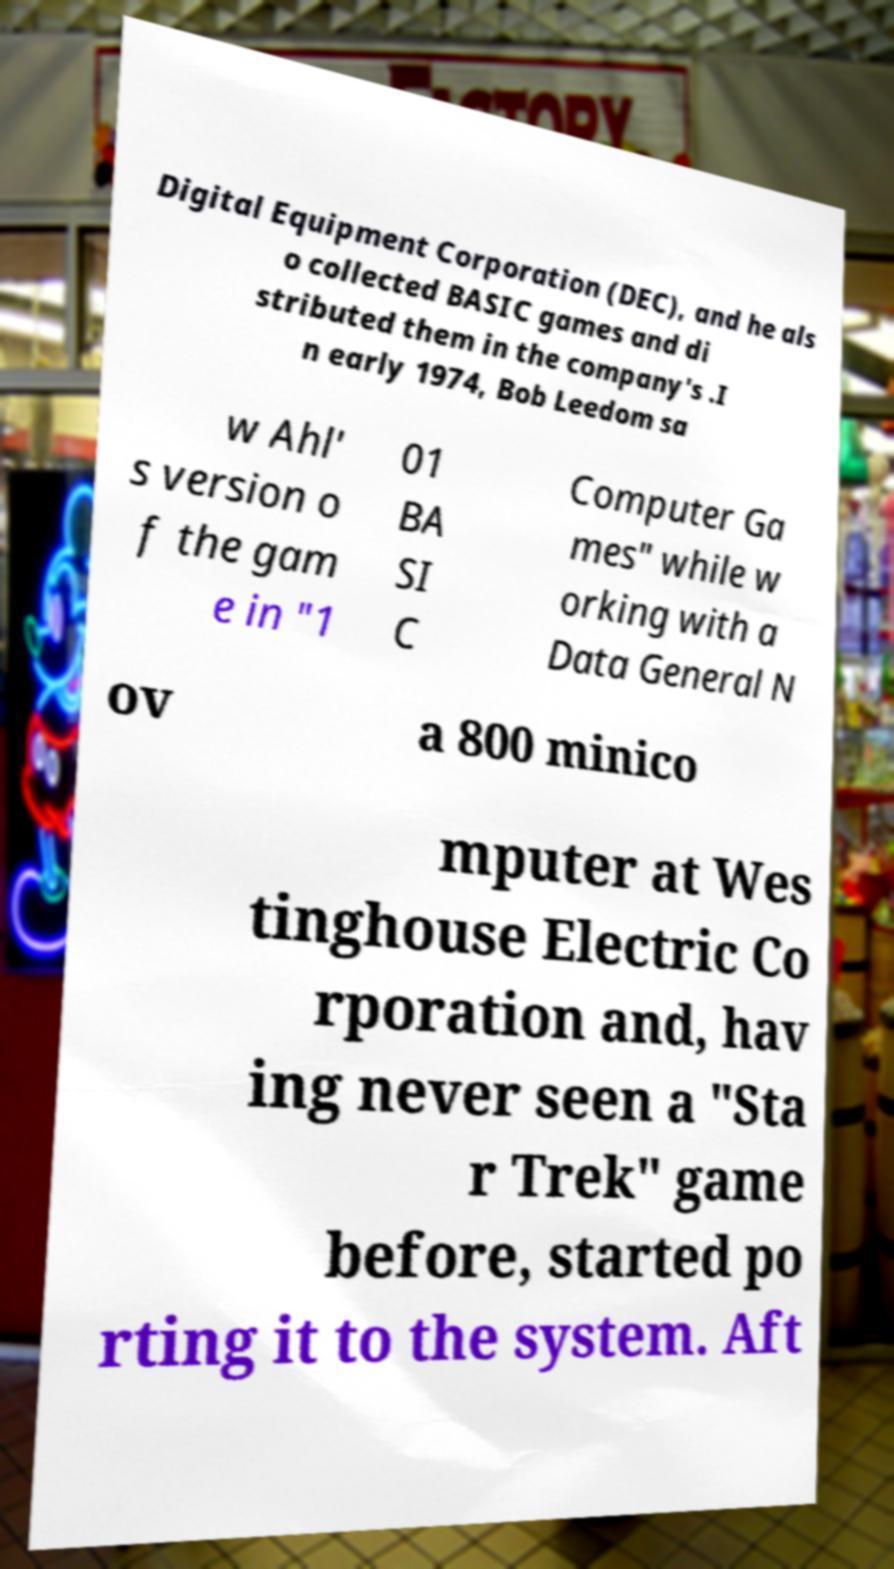What messages or text are displayed in this image? I need them in a readable, typed format. Digital Equipment Corporation (DEC), and he als o collected BASIC games and di stributed them in the company's .I n early 1974, Bob Leedom sa w Ahl' s version o f the gam e in "1 01 BA SI C Computer Ga mes" while w orking with a Data General N ov a 800 minico mputer at Wes tinghouse Electric Co rporation and, hav ing never seen a "Sta r Trek" game before, started po rting it to the system. Aft 